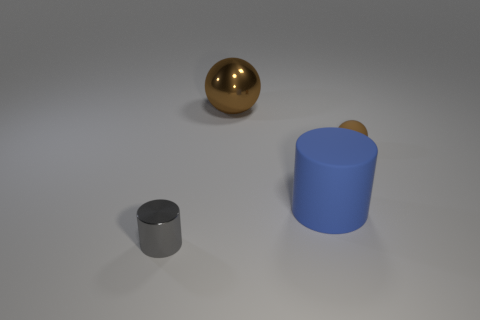Subtract 1 spheres. How many spheres are left? 1 Add 3 large cylinders. How many objects exist? 7 Subtract all blue cylinders. How many cylinders are left? 1 Add 2 big things. How many big things are left? 4 Add 2 large matte balls. How many large matte balls exist? 2 Subtract 0 gray spheres. How many objects are left? 4 Subtract all blue cylinders. Subtract all brown blocks. How many cylinders are left? 1 Subtract all gray cubes. How many blue spheres are left? 0 Subtract all cylinders. Subtract all big blue cylinders. How many objects are left? 1 